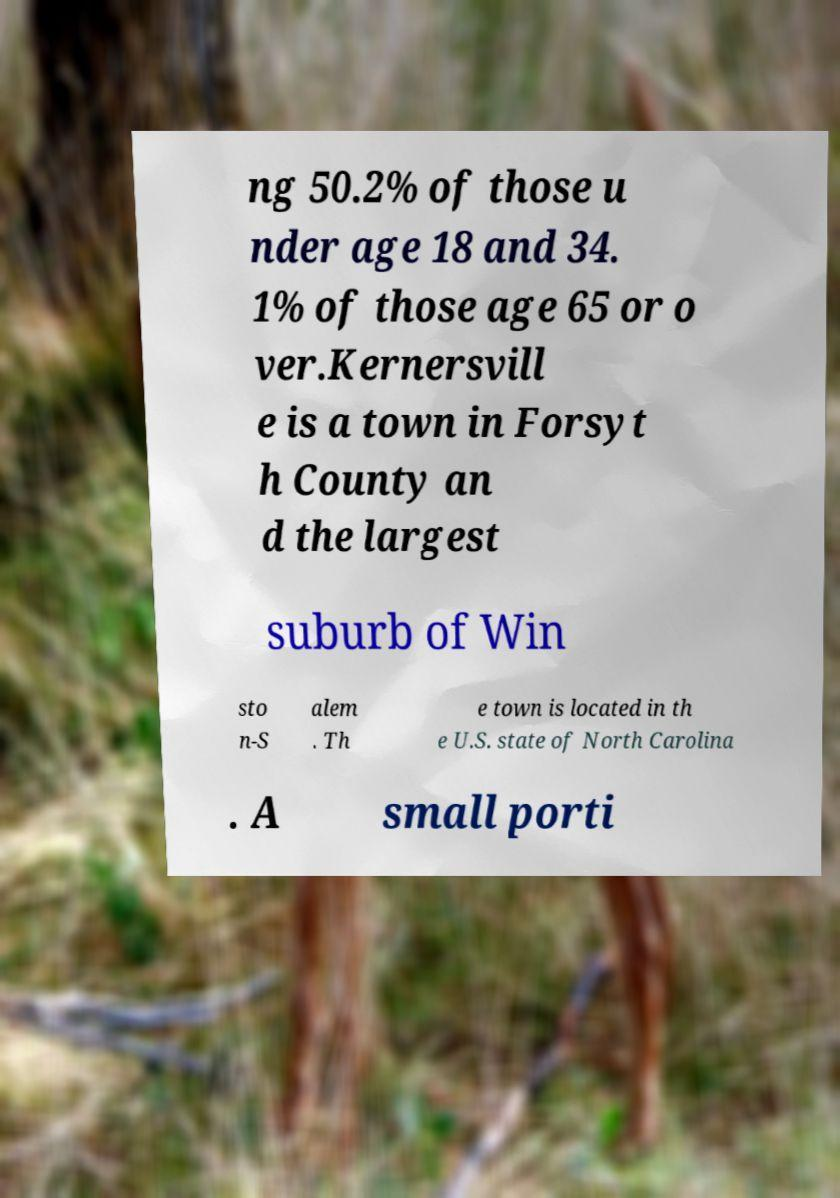Please identify and transcribe the text found in this image. ng 50.2% of those u nder age 18 and 34. 1% of those age 65 or o ver.Kernersvill e is a town in Forsyt h County an d the largest suburb of Win sto n-S alem . Th e town is located in th e U.S. state of North Carolina . A small porti 